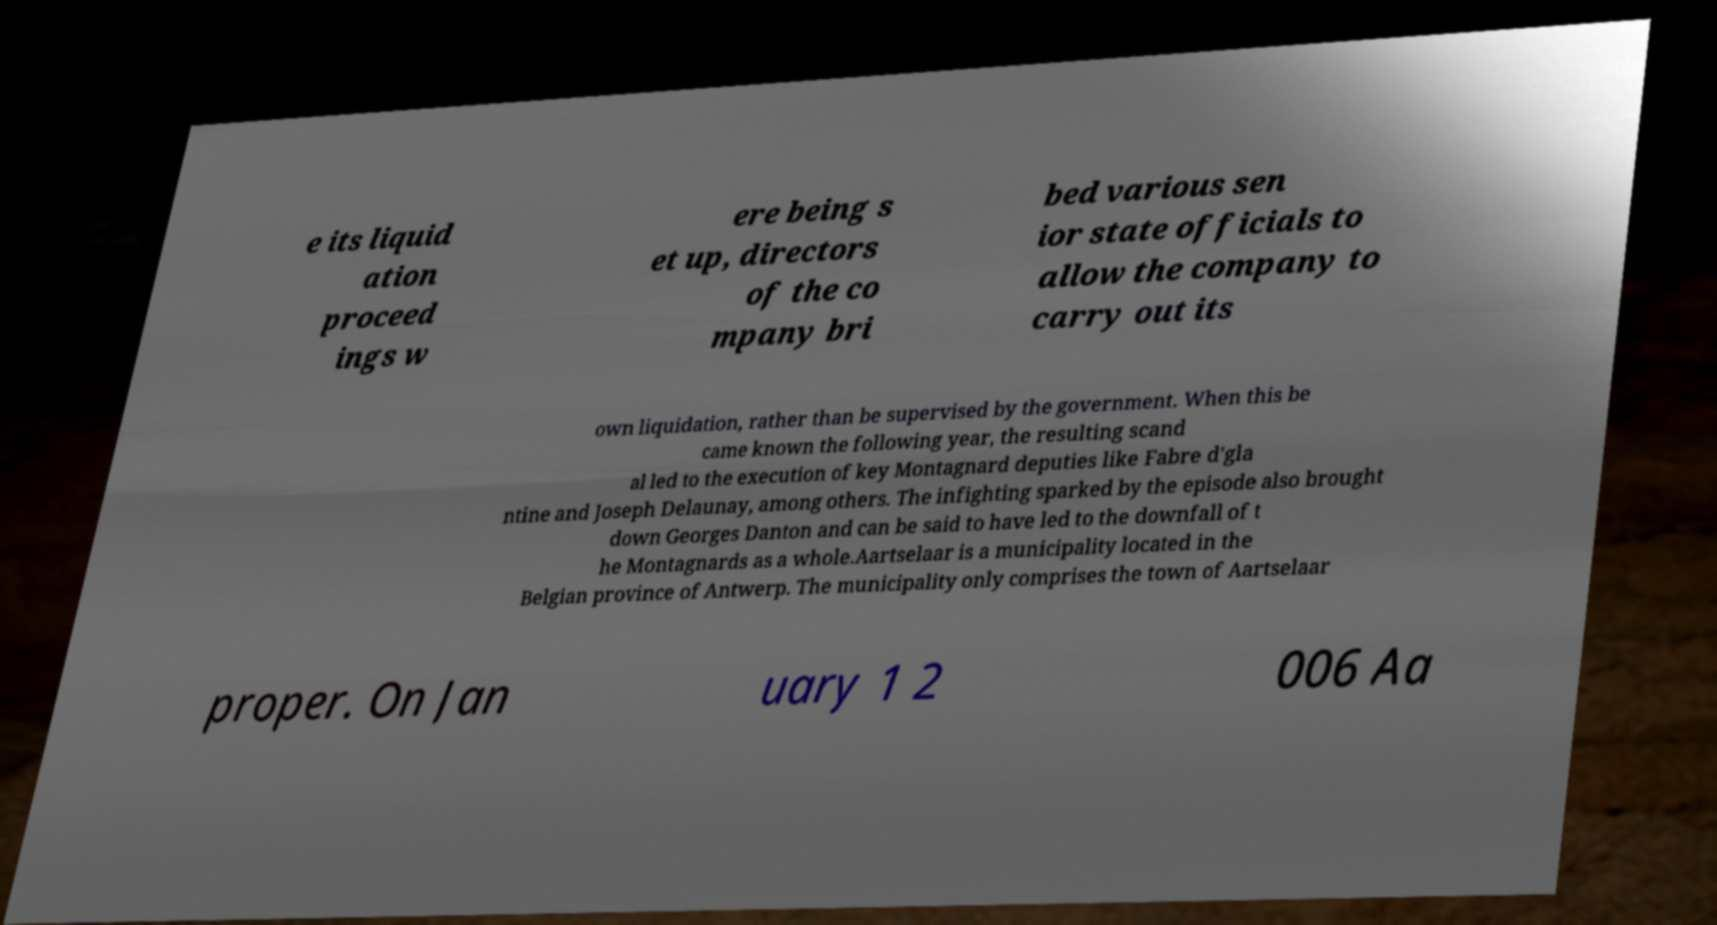Please read and relay the text visible in this image. What does it say? e its liquid ation proceed ings w ere being s et up, directors of the co mpany bri bed various sen ior state officials to allow the company to carry out its own liquidation, rather than be supervised by the government. When this be came known the following year, the resulting scand al led to the execution of key Montagnard deputies like Fabre d'gla ntine and Joseph Delaunay, among others. The infighting sparked by the episode also brought down Georges Danton and can be said to have led to the downfall of t he Montagnards as a whole.Aartselaar is a municipality located in the Belgian province of Antwerp. The municipality only comprises the town of Aartselaar proper. On Jan uary 1 2 006 Aa 